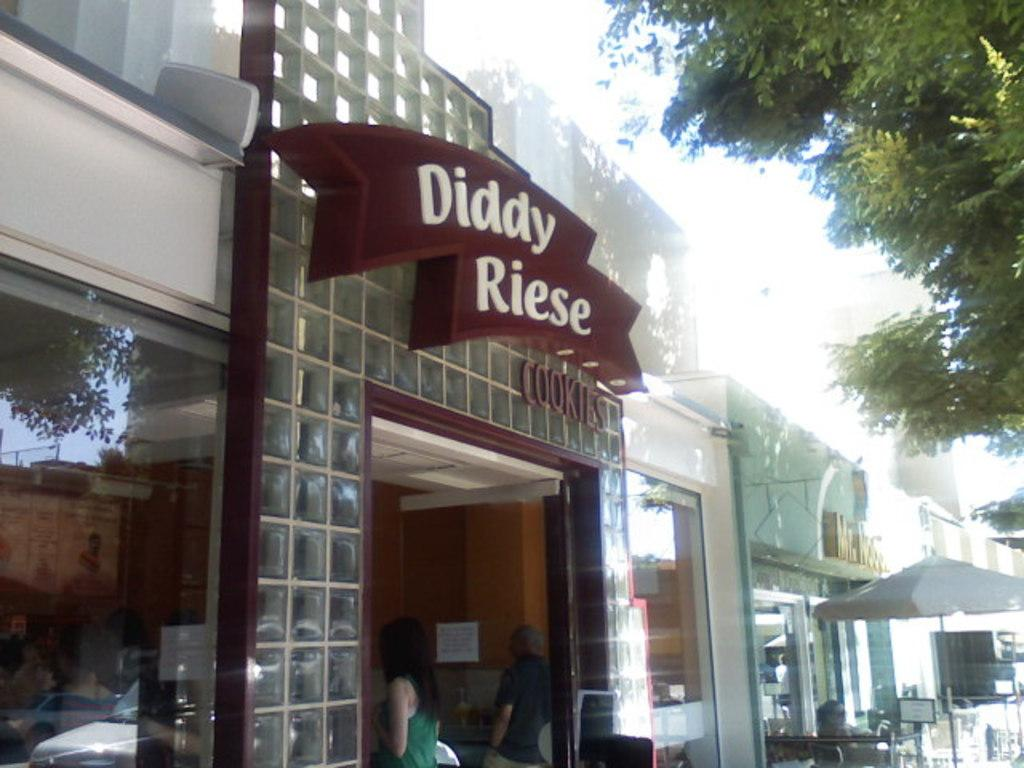What object is present in the image to provide shade or protection from the elements? There is an umbrella in the image. What type of natural scenery can be seen in the image? There are trees in the image. What type of man-made structures are visible in the image? There are buildings in the image. What type of furniture is present in the image? There is a table in the image. What type of decoration is present on the wall in the image? There is a wall with a poster on it in the image. How many people are present in the image? There are people in the image. What is the fifth person doing in the image? There is no mention of a fifth person in the image, as the fact only states that there are people present. 